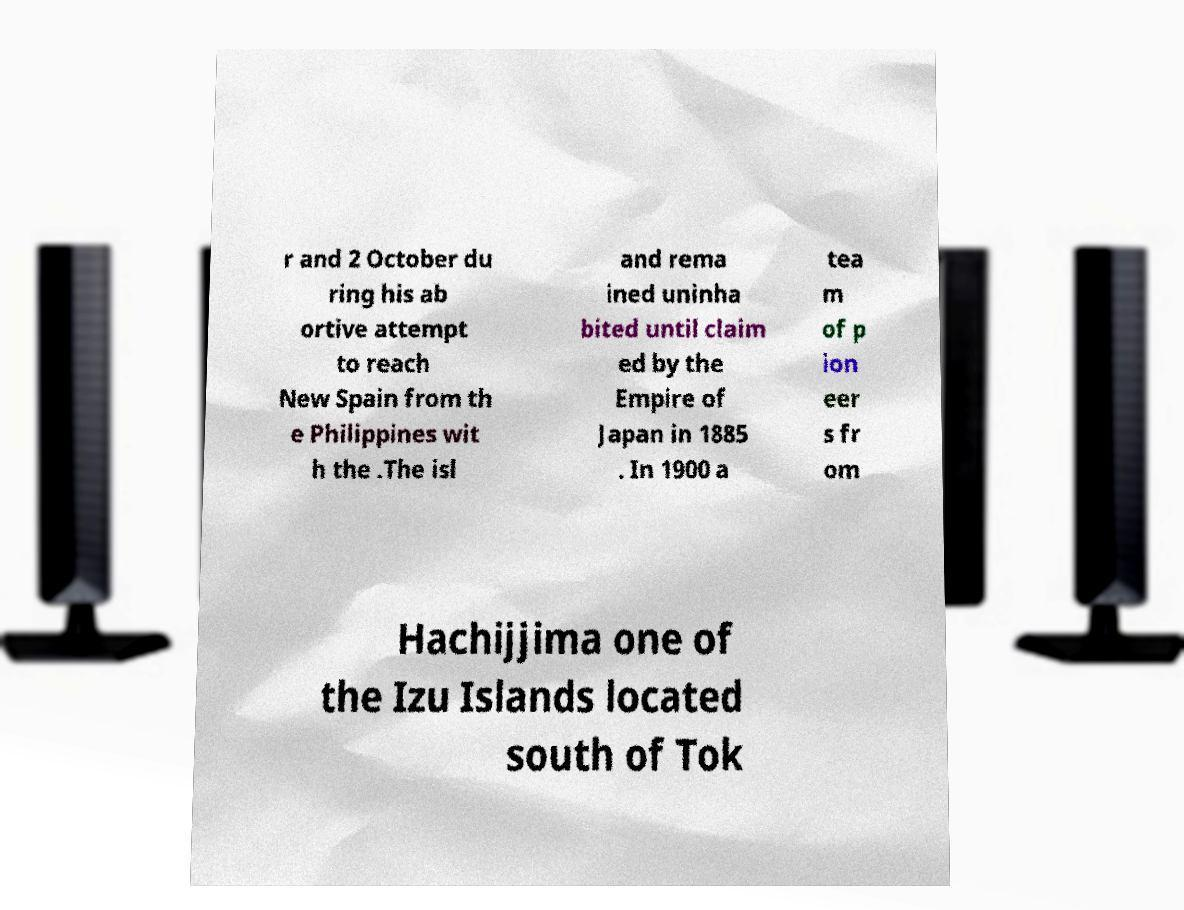For documentation purposes, I need the text within this image transcribed. Could you provide that? r and 2 October du ring his ab ortive attempt to reach New Spain from th e Philippines wit h the .The isl and rema ined uninha bited until claim ed by the Empire of Japan in 1885 . In 1900 a tea m of p ion eer s fr om Hachijjima one of the Izu Islands located south of Tok 